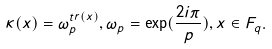Convert formula to latex. <formula><loc_0><loc_0><loc_500><loc_500>\kappa ( x ) = \omega _ { p } ^ { t r ( x ) } , \omega _ { p } = \exp ( \frac { 2 i \pi } { p } ) , x \in F _ { q } .</formula> 